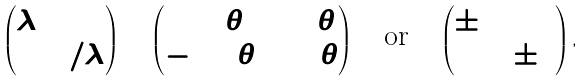Convert formula to latex. <formula><loc_0><loc_0><loc_500><loc_500>\begin{pmatrix} \lambda & 0 \\ 0 & 1 / \lambda \end{pmatrix} \quad \begin{pmatrix} \cos \theta & \sin \theta \\ - \sin \theta & \cos \theta \end{pmatrix} \quad \text {or} \quad \begin{pmatrix} \pm 1 & 1 \\ 0 & \pm 1 \end{pmatrix} ,</formula> 